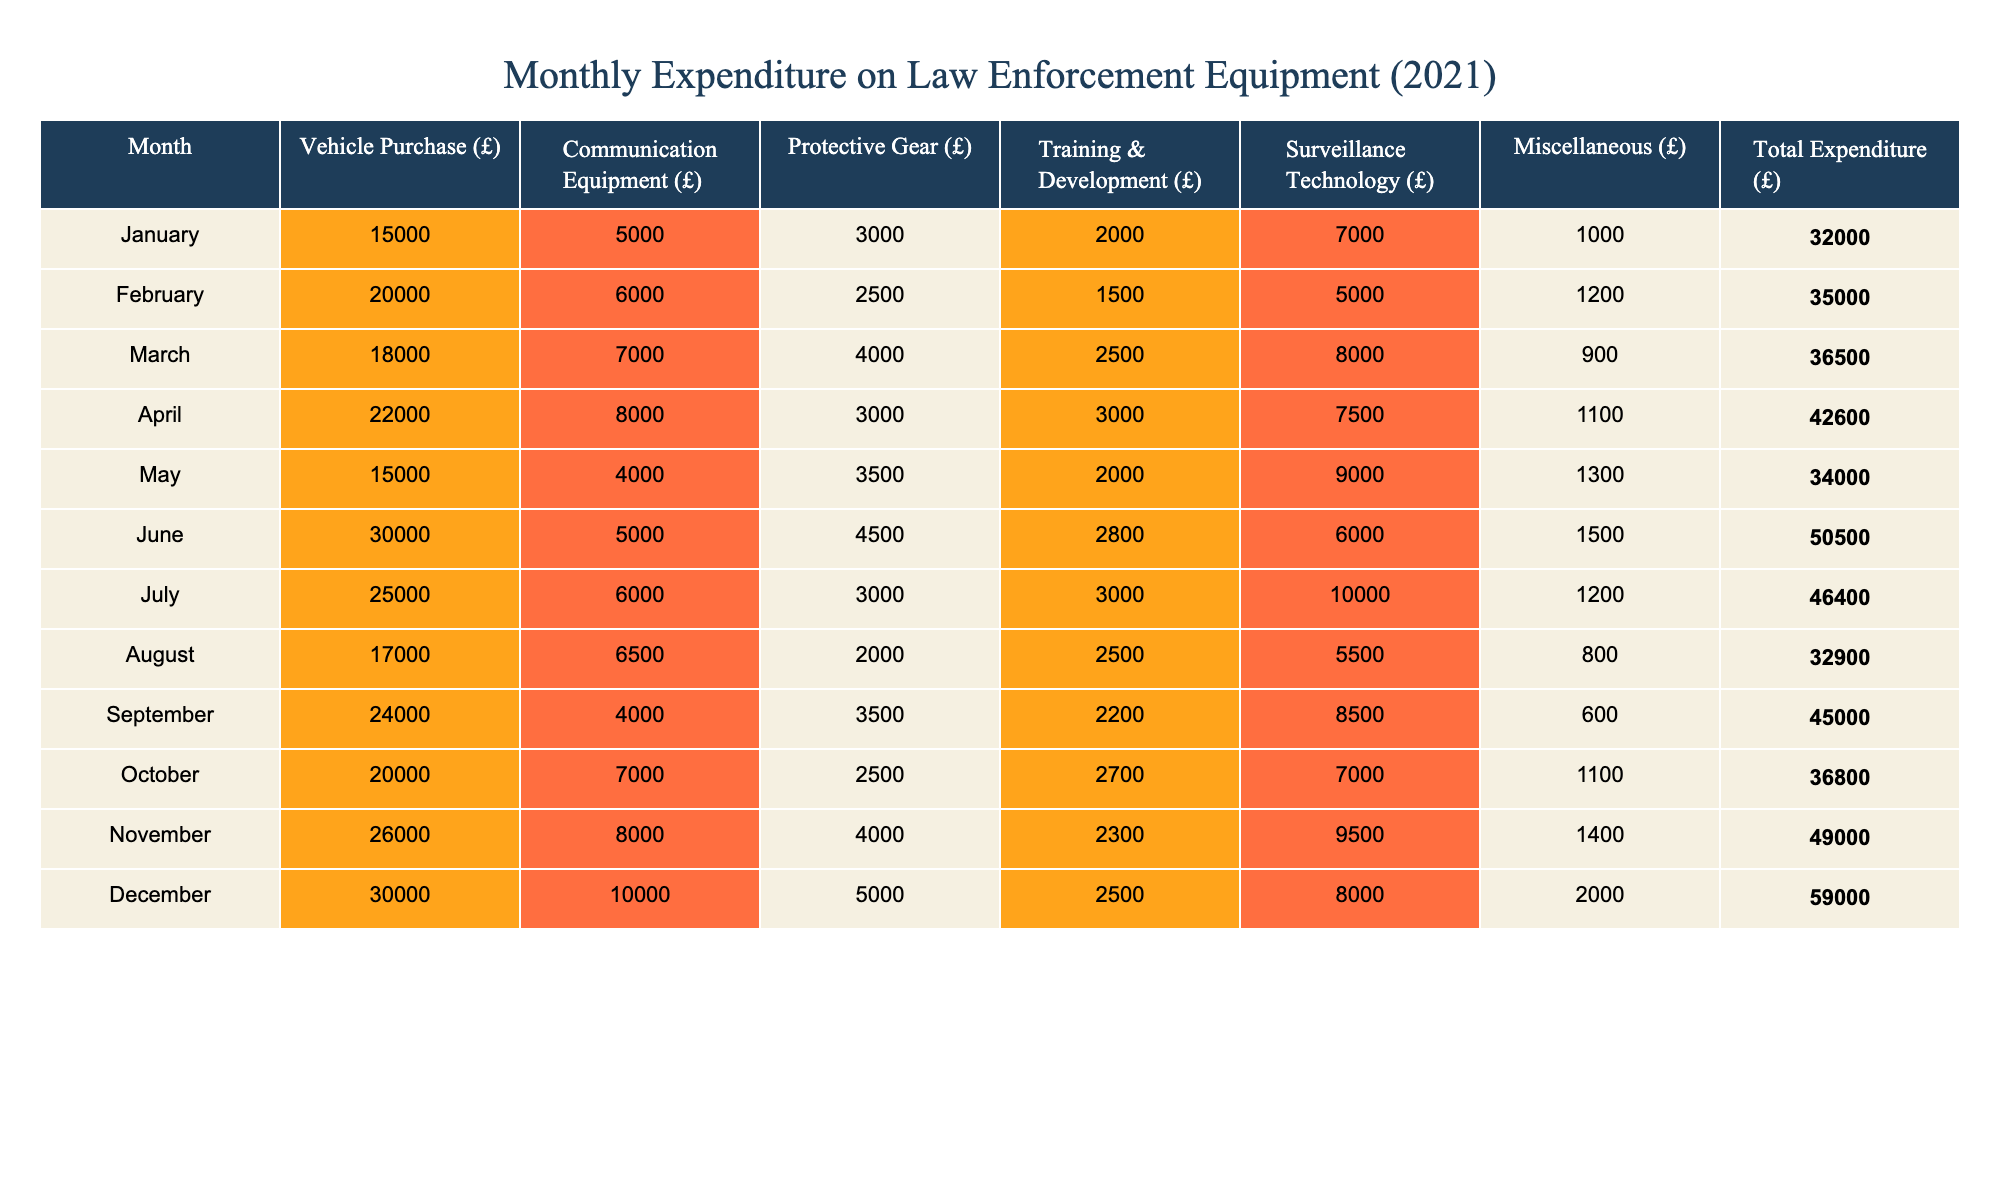What was the total expenditure for June? Looking at the 'Total Expenditure (£)' column for June, the value is bolded as 50500.
Answer: 50500 Which month had the highest expenditure on Vehicle Purchase? By examining the 'Vehicle Purchase (£)' column, April has the highest value of 22000.
Answer: 22000 What is the average expenditure on Protective Gear over the year? The values for Protective Gear are: 3000, 2500, 4000, 3000, 3500, 4500, 3000, 2000, 3500, 2500, 4000, 5000. Their sum is 37500. Dividing this by 12 gives an average of 3125.
Answer: 3125 Did the expenditure on Surveillance Technology ever exceed 8000? By checking the 'Surveillance Technology (£)' column, the maximum value is 10000 in December, confirming that it did exceed 8000.
Answer: Yes In which month did the total expenditure exceed 40000 for the first time? Reviewing the 'Total Expenditure (£)' column, we see January is 32000, February 35000, March 36500, and April 42600. April is the first month above 40000.
Answer: April What is the difference in total expenditure between the highest and lowest months? The highest expenditure is in December at 59000, and the lowest is in January at 32000. Subtracting these (59000 - 32000) gives a difference of 27000.
Answer: 27000 Which item had the least expenditure in any month? Looking closely at all items listed for each month, August has the lowest expenditure on Miscellaneous at 800.
Answer: 800 How many months had total expenditures over 45000? The months with expenditures above 45000 are April (42600), June (50500), July (46400), November (49000), and December (59000). This counts as 5 months.
Answer: 5 What was the total expenditure for the month with the least investment in Communication Equipment? The lowest value in the 'Communication Equipment (£)' column is 4000 from September, and the total expenditure for that month was 45000.
Answer: 45000 Calculate the total expenditure for the first half of the year. Summing the total expenditures for January (32000), February (35000), March (36500), April (42600), May (34000), and June (50500) gives a total of 220600.
Answer: 220600 